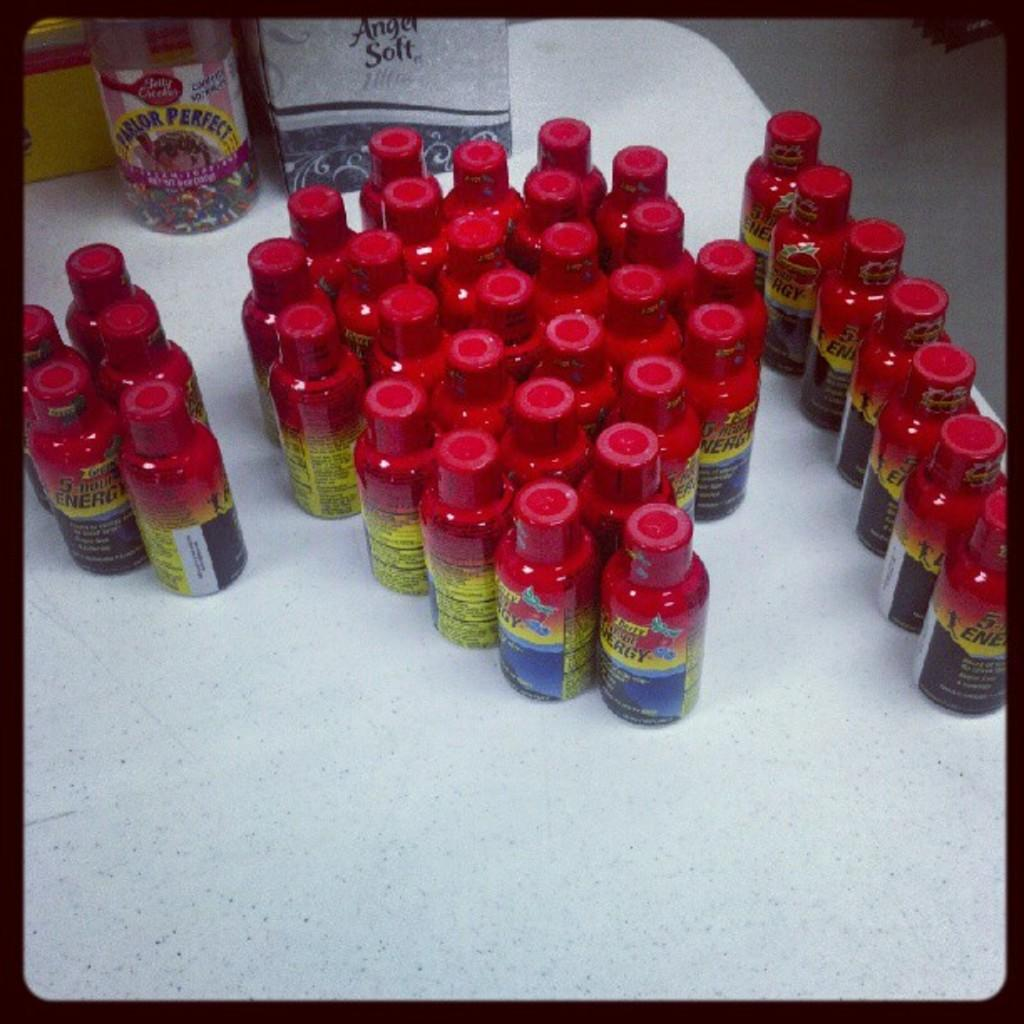What is on the table in the image? There is a group of bottles on a table in the image. Can you describe the type of bottle that is present? There is a plastic bottle in the image. What colors can be seen among the bottles? The bottles come in red, yellow, and blue colors. What type of cheese is being steamed by the mom in the image? There is no cheese or mom present in the image; it only features a group of bottles on a table. 